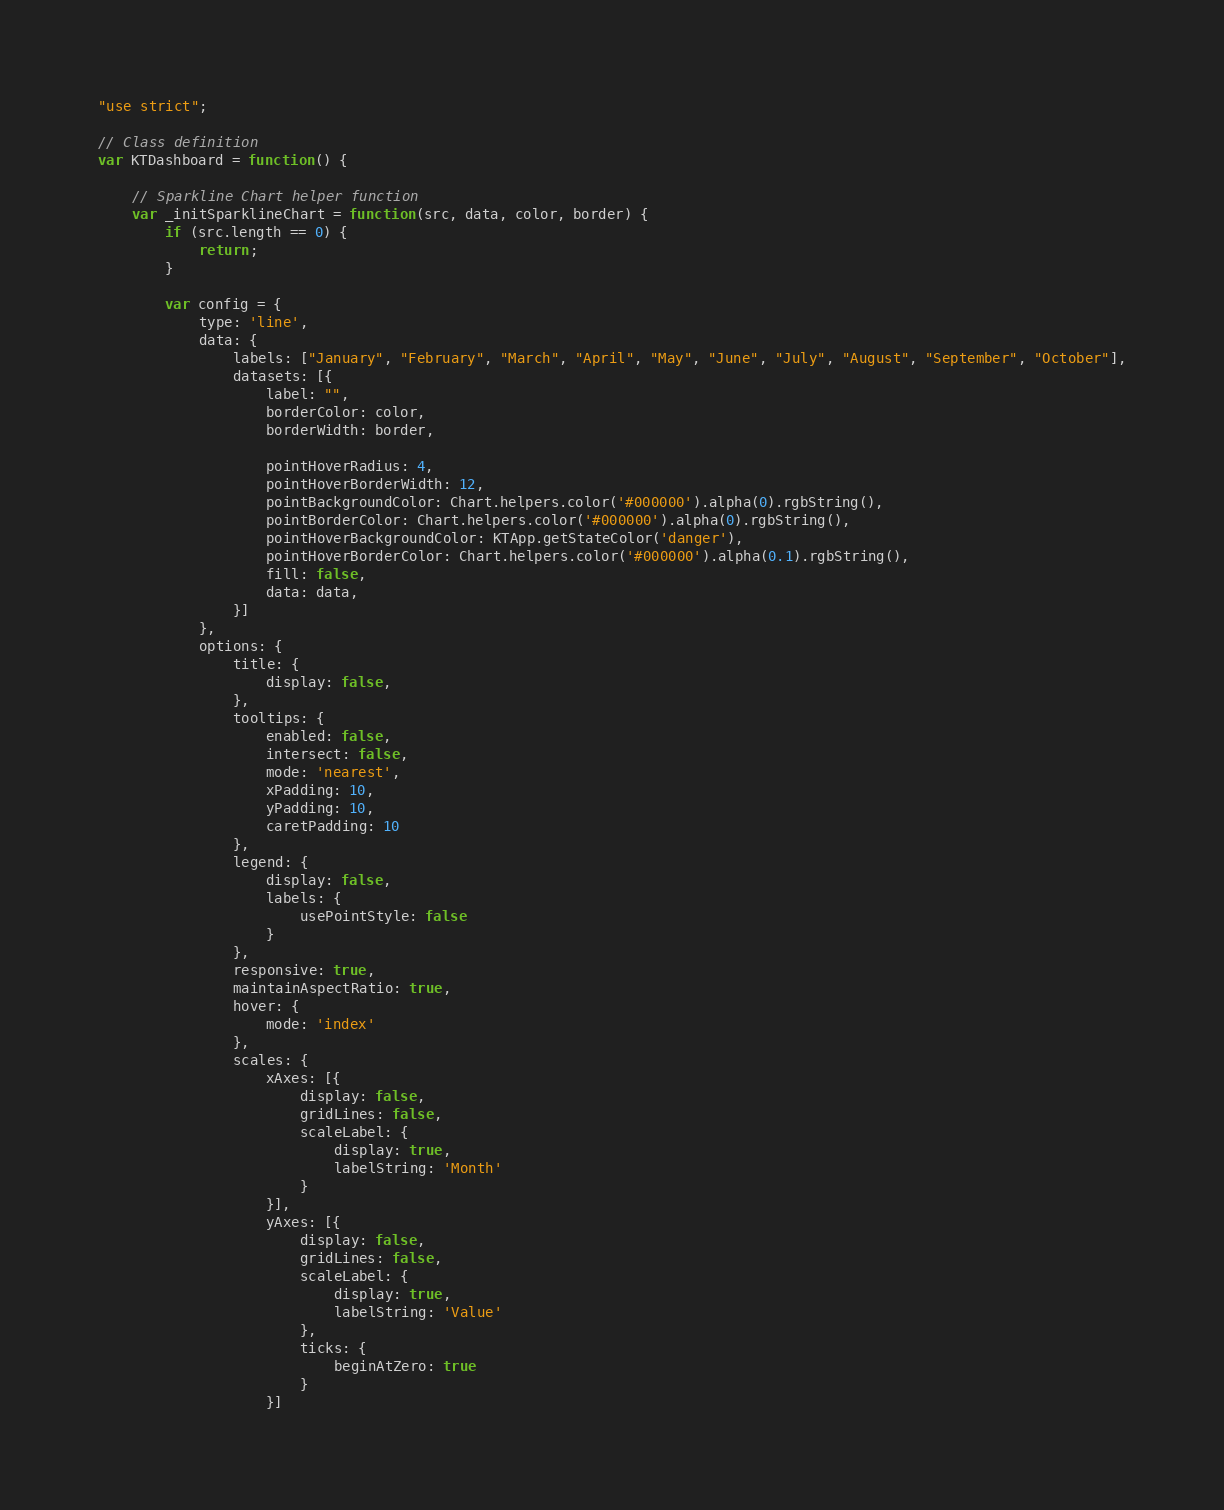Convert code to text. <code><loc_0><loc_0><loc_500><loc_500><_JavaScript_>"use strict";

// Class definition
var KTDashboard = function() {

    // Sparkline Chart helper function
    var _initSparklineChart = function(src, data, color, border) {
        if (src.length == 0) {
            return;
        }

        var config = {
            type: 'line',
            data: {
                labels: ["January", "February", "March", "April", "May", "June", "July", "August", "September", "October"],
                datasets: [{
                    label: "",
                    borderColor: color,
                    borderWidth: border,

                    pointHoverRadius: 4,
                    pointHoverBorderWidth: 12,
                    pointBackgroundColor: Chart.helpers.color('#000000').alpha(0).rgbString(),
                    pointBorderColor: Chart.helpers.color('#000000').alpha(0).rgbString(),
                    pointHoverBackgroundColor: KTApp.getStateColor('danger'),
                    pointHoverBorderColor: Chart.helpers.color('#000000').alpha(0.1).rgbString(),
                    fill: false,
                    data: data,
                }]
            },
            options: {
                title: {
                    display: false,
                },
                tooltips: {
                    enabled: false,
                    intersect: false,
                    mode: 'nearest',
                    xPadding: 10,
                    yPadding: 10,
                    caretPadding: 10
                },
                legend: {
                    display: false,
                    labels: {
                        usePointStyle: false
                    }
                },
                responsive: true,
                maintainAspectRatio: true,
                hover: {
                    mode: 'index'
                },
                scales: {
                    xAxes: [{
                        display: false,
                        gridLines: false,
                        scaleLabel: {
                            display: true,
                            labelString: 'Month'
                        }
                    }],
                    yAxes: [{
                        display: false,
                        gridLines: false,
                        scaleLabel: {
                            display: true,
                            labelString: 'Value'
                        },
                        ticks: {
                            beginAtZero: true
                        }
                    }]</code> 